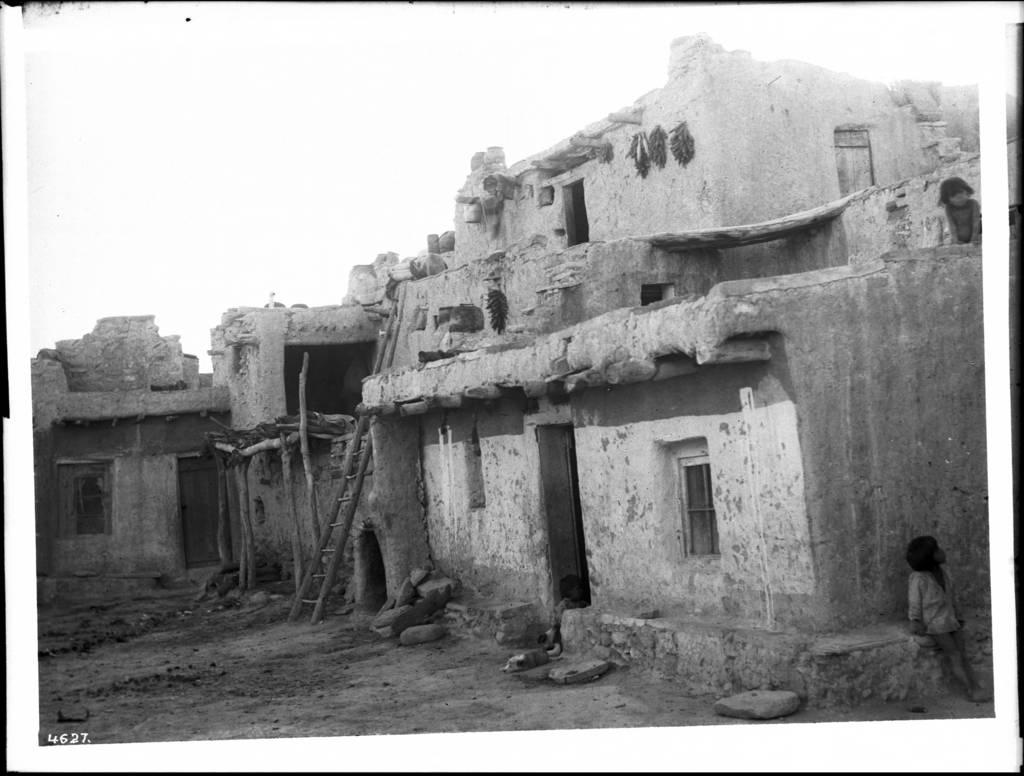What type of structures are present in the image? There are buildings in the image. What features can be seen on the buildings? The buildings have windows and doors. What object is present near the buildings? There is a ladder in the image. Who or what can be seen in the image besides the buildings? There are people in the image. What is visible in the background of the image? The sky is visible in the image. How is the image presented in terms of color? The image is in black and white. What type of marble is used to construct the buildings in the image? There is no mention of marble being used in the construction of the buildings in the image. What angle was the image taken from? The angle from which the image was taken is not mentioned in the provided facts. 